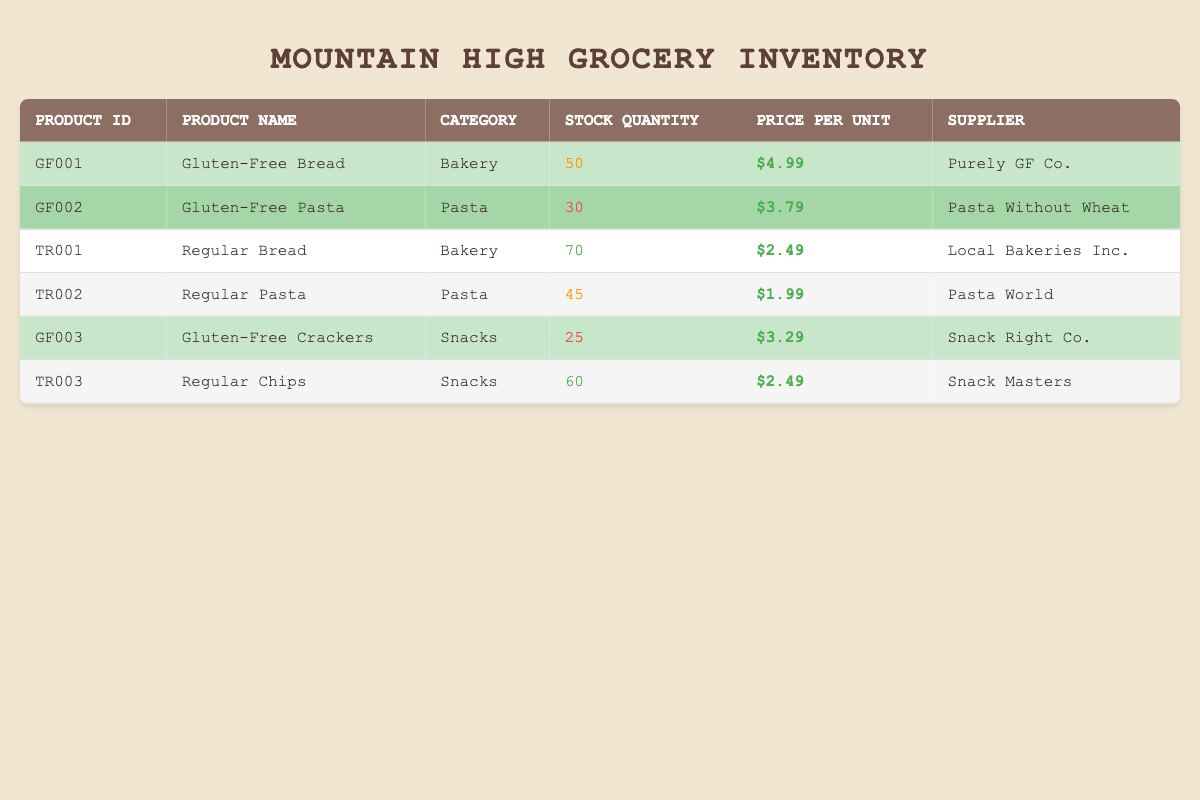What is the stock quantity of Gluten-Free Bread? The table lists Gluten-Free Bread under the product name with a stock quantity of 50.
Answer: 50 What is the price of Regular Pasta? The table specifies Regular Pasta's price per unit as $1.99.
Answer: $1.99 Is Gluten-Free Pasta categorized under Snacks? The table shows that Gluten-Free Pasta is in the Pasta category, not Snacks, therefore the answer is no.
Answer: No Which gluten-free product has the lowest stock quantity? The stock quantities for gluten-free products are as follows: Gluten-Free Bread has 50, Gluten-Free Pasta has 30, and Gluten-Free Crackers has 25. The lowest quantity is for Gluten-Free Crackers, which has 25.
Answer: Gluten-Free Crackers What is the total stock quantity of gluten-free products? The stock quantities for gluten-free products are 50 for Gluten-Free Bread, 30 for Gluten-Free Pasta, and 25 for Gluten-Free Crackers. Summing these gives 50 + 30 + 25 = 105.
Answer: 105 Which supplier provides the most stock items? To find this, we compare the stock quantities by supplier: Purely GF Co. has 50 (Gluten-Free Bread), Pasta Without Wheat has 30 (Gluten-Free Pasta), and Snack Right Co. has 25 (Gluten-Free Crackers). Traditional products have higher quantities, with Local Bakeries Inc. providing 70 (Regular Bread) and Pasta World offering 45 (Regular Pasta). Snack Masters has 60 (Regular Chips). Therefore, the supplier with the highest overall stock items is Local Bakeries Inc. with 70.
Answer: Local Bakeries Inc Is there any gluten-free product priced higher than $4? The prices for gluten-free products are: Gluten-Free Bread ($4.99), Gluten-Free Pasta ($3.79), and Gluten-Free Crackers ($3.29). Gluten-Free Bread is the only product priced higher than $4.
Answer: Yes What is the difference in stock quantity between the highest stock regular product and the lowest stock gluten-free product? The highest stock regular product is Regular Bread with a stock quantity of 70, while the lowest stock gluten-free product is Gluten-Free Crackers with 25. The difference is 70 - 25 = 45.
Answer: 45 How many gluten-free products have a stock quantity less than 40? The gluten-free products have the following stock quantities: Gluten-Free Bread (50), Gluten-Free Pasta (30), and Gluten-Free Crackers (25). Only Gluten-Free Pasta (30) and Gluten-Free Crackers (25) have stock quantities less than 40. Thus, there are 2 gluten-free products that meet this criterion.
Answer: 2 